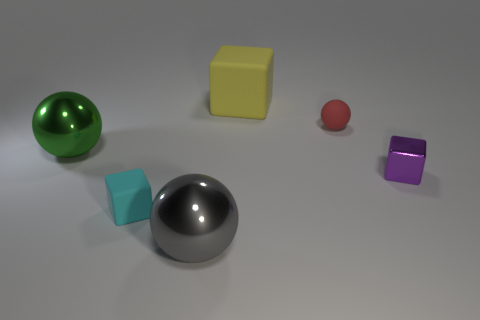Subtract all rubber cubes. How many cubes are left? 1 Subtract all gray balls. How many balls are left? 2 Add 1 yellow rubber cubes. How many objects exist? 7 Subtract all red cubes. How many green spheres are left? 1 Subtract all purple shiny cubes. Subtract all red metal blocks. How many objects are left? 5 Add 2 small cyan blocks. How many small cyan blocks are left? 3 Add 1 gray spheres. How many gray spheres exist? 2 Subtract 0 blue cubes. How many objects are left? 6 Subtract 1 cubes. How many cubes are left? 2 Subtract all green blocks. Subtract all blue cylinders. How many blocks are left? 3 